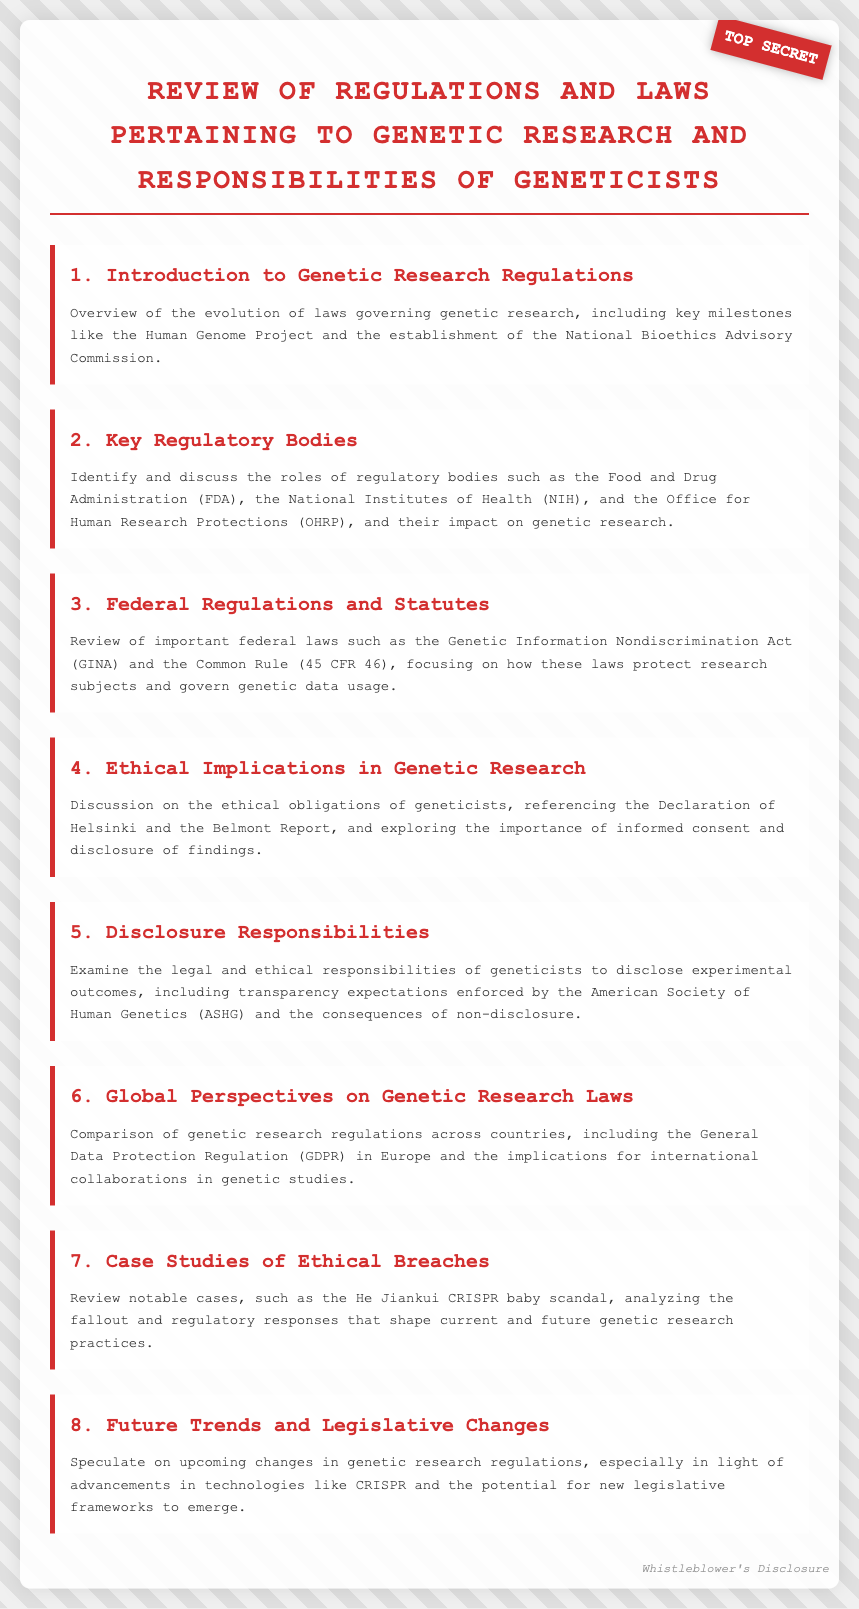What is the title of the agenda? The title is found at the top of the document, summarizing the main topic of discussion.
Answer: Review of Regulations and Laws Pertaining to Genetic Research and Responsibilities of Geneticists How many agenda items are listed? The number of agenda items can be counted from the sections of the document.
Answer: 8 What key regulatory body is mentioned in the second item? The key regulatory body is explicitly stated in the section heading and description.
Answer: Food and Drug Administration (FDA) What is the focus of the third agenda item? The specific focus is clearly stated in the section heading and expanded upon in the summary.
Answer: Federal laws such as the Genetic Information Nondiscrimination Act (GINA) Which document sets ethical obligations for geneticists? This document is referenced in the fourth agenda item, specifically relating to ethics.
Answer: Declaration of Helsinki Which scandal is mentioned in the case studies section? The name of the scandal is included in the description of the seventh agenda item.
Answer: He Jiankui CRISPR baby scandal What does the last item speculate about? The speculation is noted in the summary of the eighth agenda item, suggesting what might occur in the future.
Answer: Upcoming changes in genetic research regulations What role does the American Society of Human Genetics play in the fifth agenda item? The document highlights the organization's focus concerning the responsibilities of geneticists.
Answer: Transparency expectations 